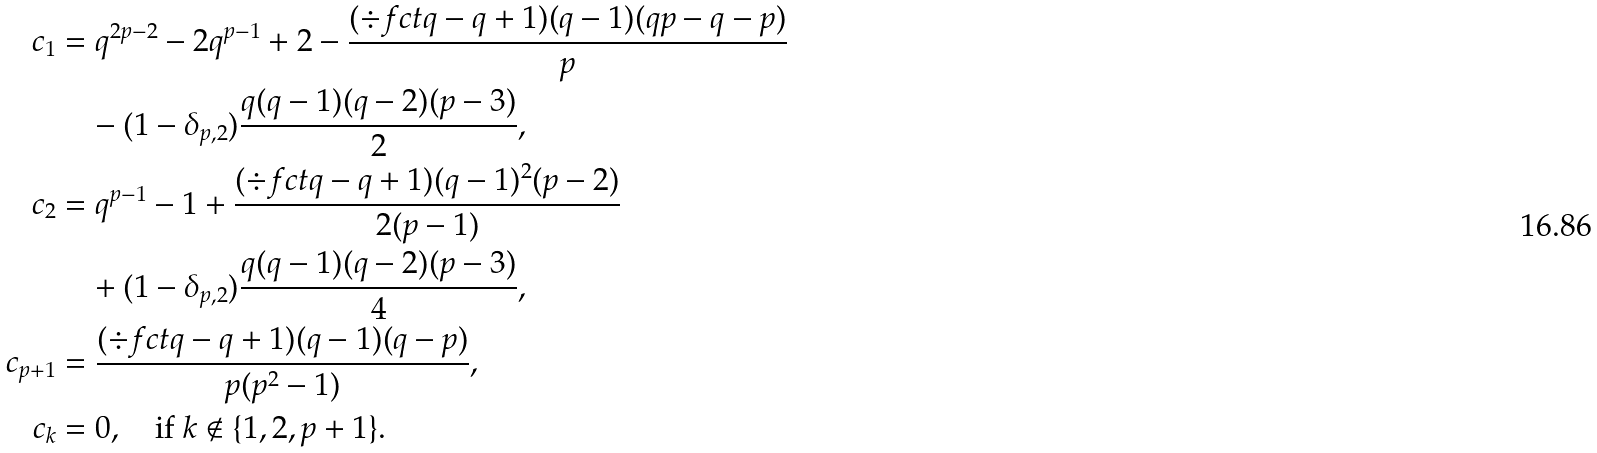<formula> <loc_0><loc_0><loc_500><loc_500>c _ { 1 } & = q ^ { 2 p - 2 } - 2 q ^ { p - 1 } + 2 - \frac { ( \div f c t q - q + 1 ) ( q - 1 ) ( q p - q - p ) } { p } \\ & \quad - ( 1 - \delta _ { p , 2 } ) \frac { q ( q - 1 ) ( q - 2 ) ( p - 3 ) } { 2 } , \\ c _ { 2 } & = q ^ { p - 1 } - 1 + \frac { ( \div f c t q - q + 1 ) ( q - 1 ) ^ { 2 } ( p - 2 ) } { 2 ( p - 1 ) } \\ & \quad + ( 1 - \delta _ { p , 2 } ) \frac { q ( q - 1 ) ( q - 2 ) ( p - 3 ) } { 4 } , \\ c _ { p + 1 } & = \frac { ( \div f c t q - q + 1 ) ( q - 1 ) ( q - p ) } { p ( p ^ { 2 } - 1 ) } , \\ c _ { k } & = 0 , \quad \text {if $k \notin \{1, 2, p+1\}$} .</formula> 